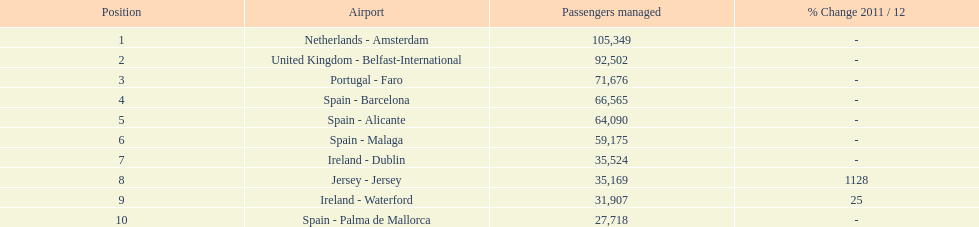What is the name of the only airport in portugal that is among the 10 busiest routes to and from london southend airport in 2012? Portugal - Faro. 